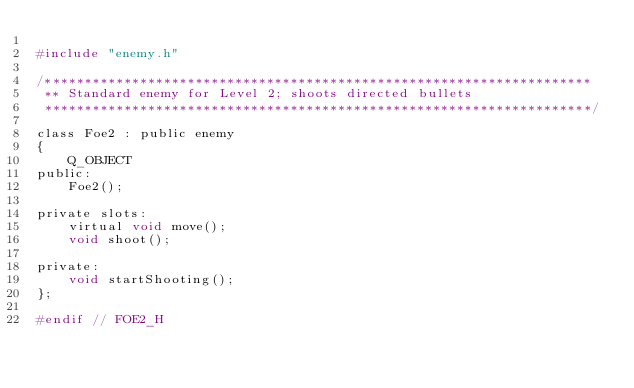Convert code to text. <code><loc_0><loc_0><loc_500><loc_500><_C_>
#include "enemy.h"

/*********************************************************************
 ** Standard enemy for Level 2; shoots directed bullets
 *********************************************************************/

class Foe2 : public enemy
{
    Q_OBJECT
public:
    Foe2();

private slots:
    virtual void move();
    void shoot();

private:
    void startShooting();
};

#endif // FOE2_H
</code> 